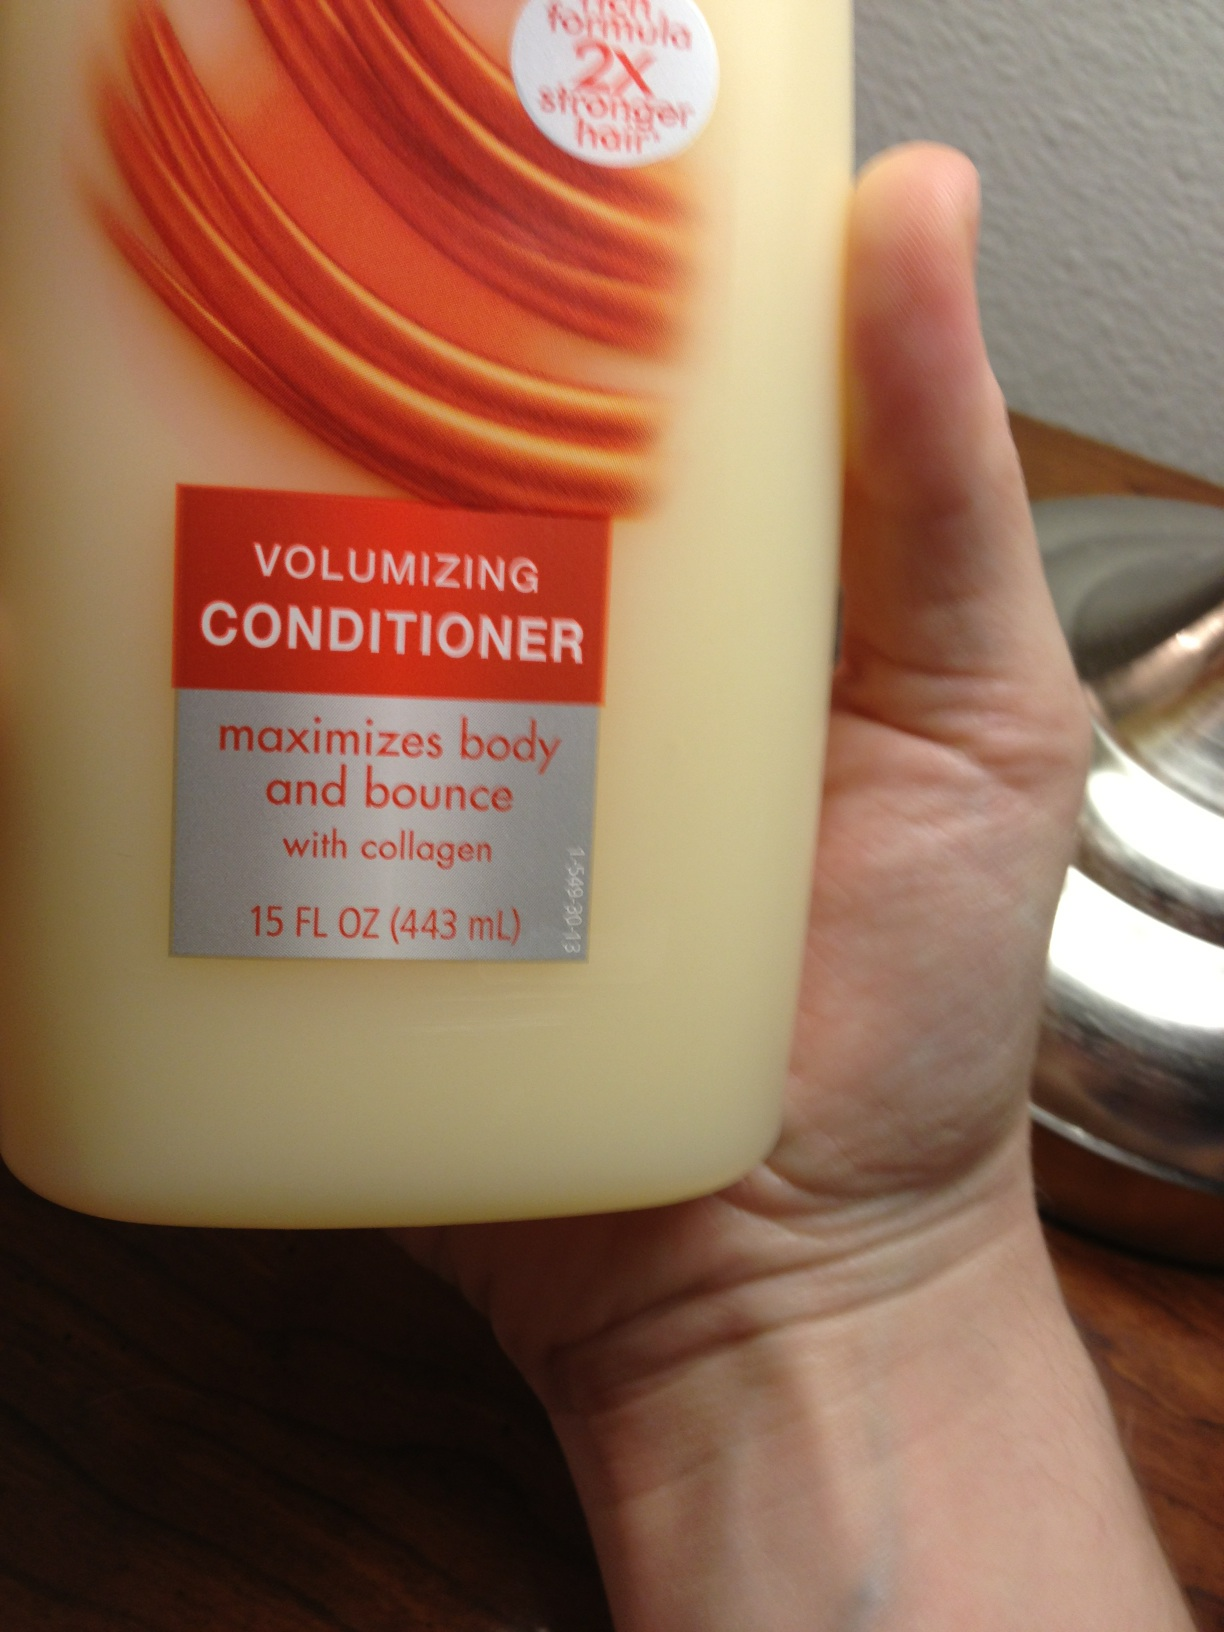Is this shampoo? Despite the similar appearance, the product in the image is not shampoo but actually a volumizing conditioner designed to add body and bounce to hair. It contains collagen and boasts a formula that claims to make hair twice as strong. 